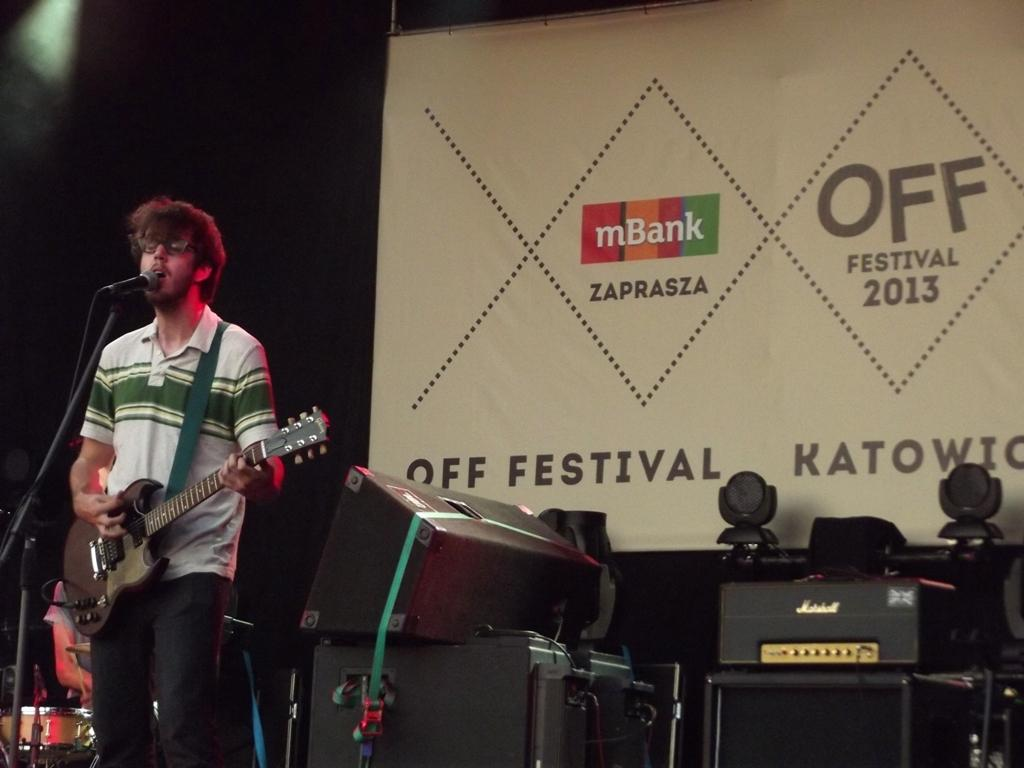What is the man in the image doing? The man is singing on a mic and playing a guitar. Is there anyone else playing a musical instrument in the image? Yes, there is a person playing a musical instrument behind the man. What can be seen in the image that amplifies sound? There are speakers in the image. What is hanging in the background of the image? There is a banner in the image. How many bridges can be seen in the image? There are no bridges present in the image. What type of tail is visible on the person playing the musical instrument? There is no tail visible on the person playing the musical instrument, as humans do not have tails. 